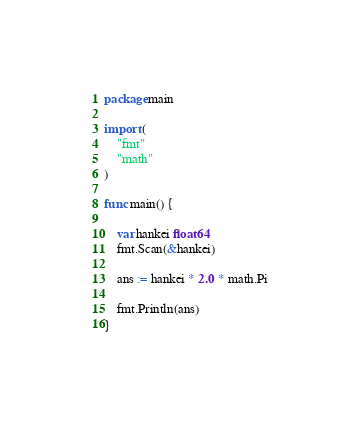Convert code to text. <code><loc_0><loc_0><loc_500><loc_500><_Go_>package main

import (
    "fmt"
    "math"
)

func main() {
    
    var hankei float64
    fmt.Scan(&hankei)

    ans := hankei * 2.0 * math.Pi

    fmt.Println(ans)
}
</code> 